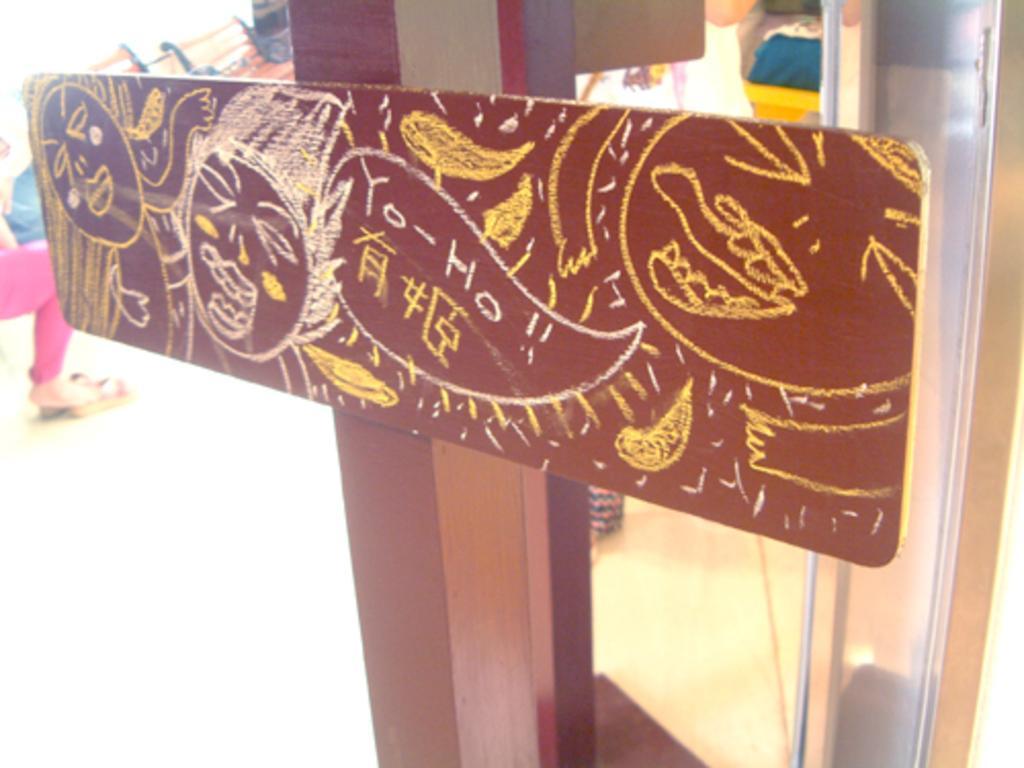Please provide a concise description of this image. In this picture I can see there is a board attached to a pole and there is some drawings on it. Onto left there is a woman sitting and there is a person standing to the right side. 